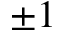<formula> <loc_0><loc_0><loc_500><loc_500>\pm 1</formula> 